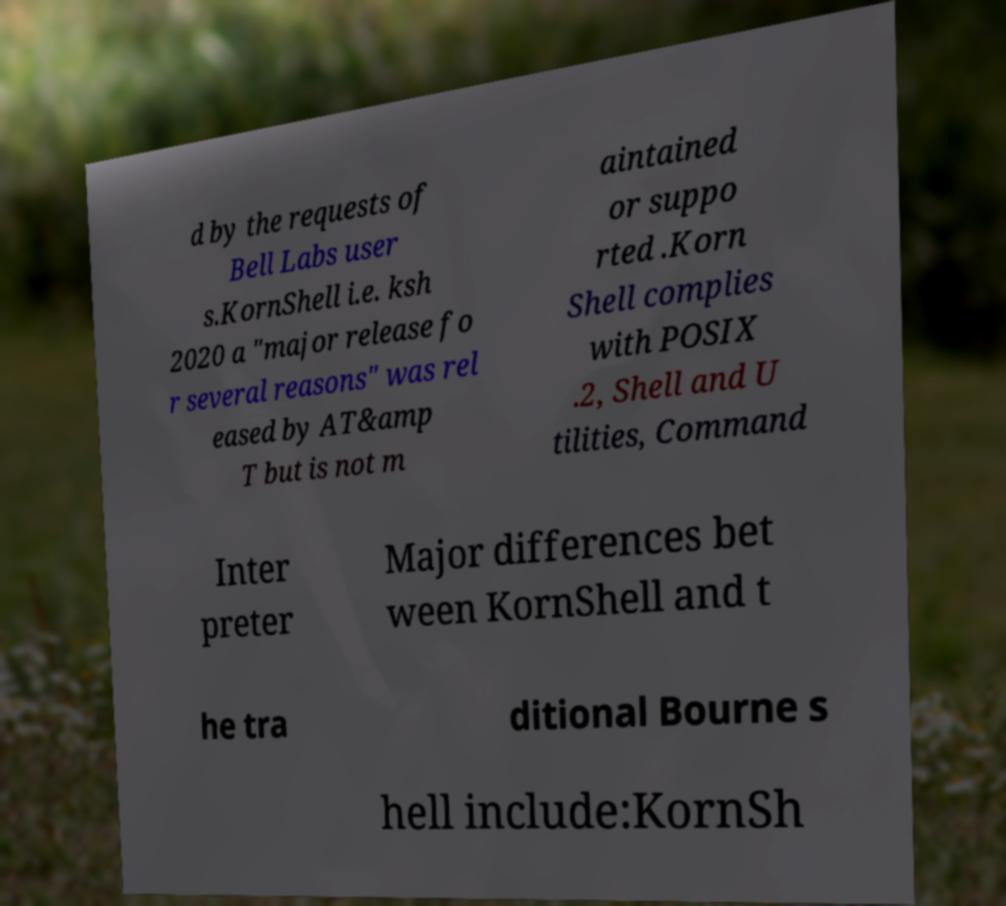There's text embedded in this image that I need extracted. Can you transcribe it verbatim? d by the requests of Bell Labs user s.KornShell i.e. ksh 2020 a "major release fo r several reasons" was rel eased by AT&amp T but is not m aintained or suppo rted .Korn Shell complies with POSIX .2, Shell and U tilities, Command Inter preter Major differences bet ween KornShell and t he tra ditional Bourne s hell include:KornSh 